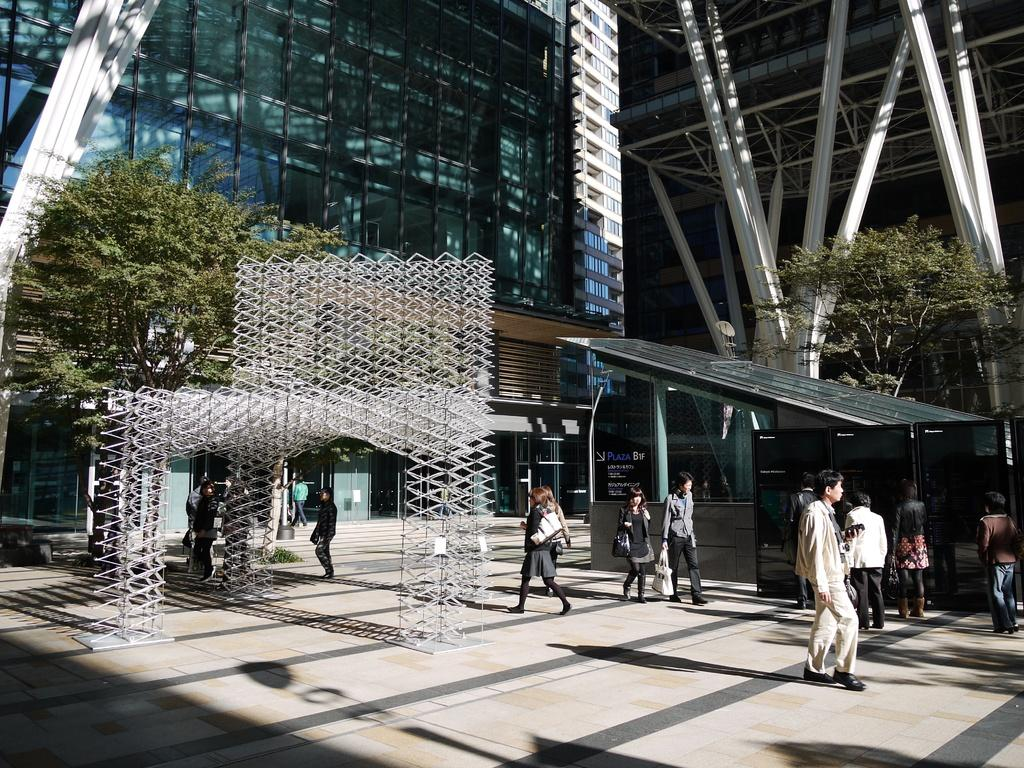What type of structure is visible in the image? There is a building in the image. What architectural elements can be seen in the image? There are beams visible in the image. What natural elements are present in the image? There are trees in the image. What type of sign or notice might be present in the image? There is a board in the image. What else can be seen in the image besides the building, beams, trees, and board? There are other objects in the image. Are there any people present in the image? Yes, there are people in the image. How is the distribution of the quiver managed in the image? There is no quiver present in the image, so its distribution cannot be managed. 